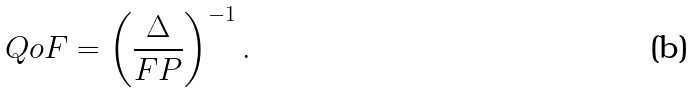Convert formula to latex. <formula><loc_0><loc_0><loc_500><loc_500>Q o F = \left ( \frac { \Delta } { F P } \right ) ^ { - 1 } .</formula> 